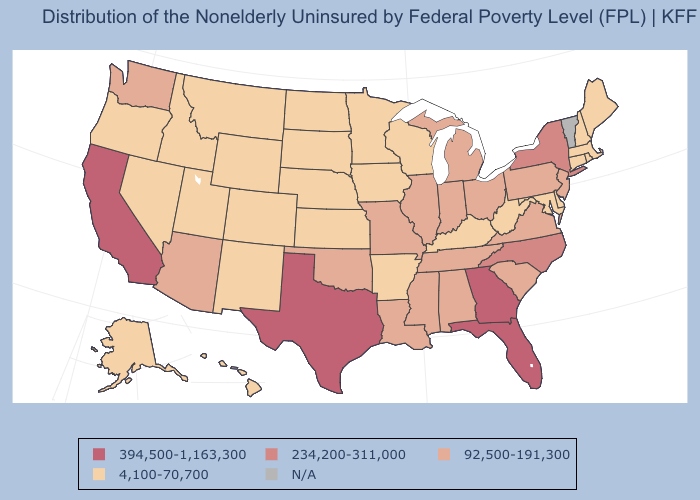Is the legend a continuous bar?
Quick response, please. No. What is the value of Iowa?
Quick response, please. 4,100-70,700. Which states have the lowest value in the USA?
Concise answer only. Alaska, Arkansas, Colorado, Connecticut, Delaware, Hawaii, Idaho, Iowa, Kansas, Kentucky, Maine, Maryland, Massachusetts, Minnesota, Montana, Nebraska, Nevada, New Hampshire, New Mexico, North Dakota, Oregon, Rhode Island, South Dakota, Utah, West Virginia, Wisconsin, Wyoming. Name the states that have a value in the range N/A?
Short answer required. Vermont. Name the states that have a value in the range 92,500-191,300?
Give a very brief answer. Alabama, Arizona, Illinois, Indiana, Louisiana, Michigan, Mississippi, Missouri, New Jersey, Ohio, Oklahoma, Pennsylvania, South Carolina, Tennessee, Virginia, Washington. Name the states that have a value in the range 394,500-1,163,300?
Give a very brief answer. California, Florida, Georgia, Texas. Name the states that have a value in the range 394,500-1,163,300?
Give a very brief answer. California, Florida, Georgia, Texas. Name the states that have a value in the range 394,500-1,163,300?
Concise answer only. California, Florida, Georgia, Texas. Name the states that have a value in the range 92,500-191,300?
Short answer required. Alabama, Arizona, Illinois, Indiana, Louisiana, Michigan, Mississippi, Missouri, New Jersey, Ohio, Oklahoma, Pennsylvania, South Carolina, Tennessee, Virginia, Washington. Does California have the highest value in the USA?
Be succinct. Yes. What is the value of Maryland?
Write a very short answer. 4,100-70,700. What is the highest value in the West ?
Answer briefly. 394,500-1,163,300. What is the highest value in the West ?
Write a very short answer. 394,500-1,163,300. Among the states that border Arkansas , does Texas have the lowest value?
Answer briefly. No. Name the states that have a value in the range N/A?
Keep it brief. Vermont. 